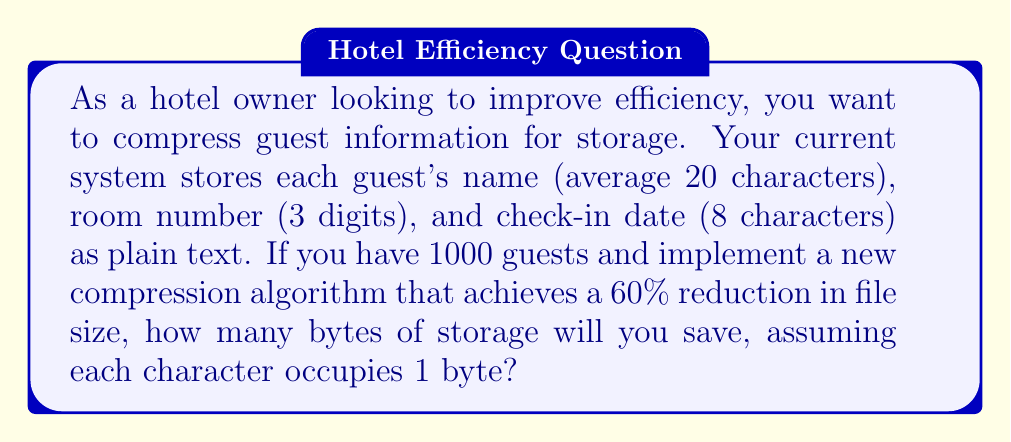Give your solution to this math problem. Let's approach this step-by-step:

1. Calculate the current storage requirement:
   - Name: 20 bytes
   - Room number: 3 bytes
   - Check-in date: 8 bytes
   - Total per guest: $20 + 3 + 8 = 31$ bytes

2. Calculate total storage for 1000 guests:
   $$ \text{Total storage} = 31 \text{ bytes} \times 1000 \text{ guests} = 31,000 \text{ bytes} $$

3. Calculate the compressed storage size:
   - 60% reduction means we keep 40% of the original size
   $$ \text{Compressed size} = 31,000 \times (1 - 0.60) = 31,000 \times 0.40 = 12,400 \text{ bytes} $$

4. Calculate the storage saved:
   $$ \text{Storage saved} = \text{Original size} - \text{Compressed size} $$
   $$ \text{Storage saved} = 31,000 - 12,400 = 18,600 \text{ bytes} $$

Thus, by implementing the compression algorithm, you will save 18,600 bytes of storage.
Answer: 18,600 bytes 